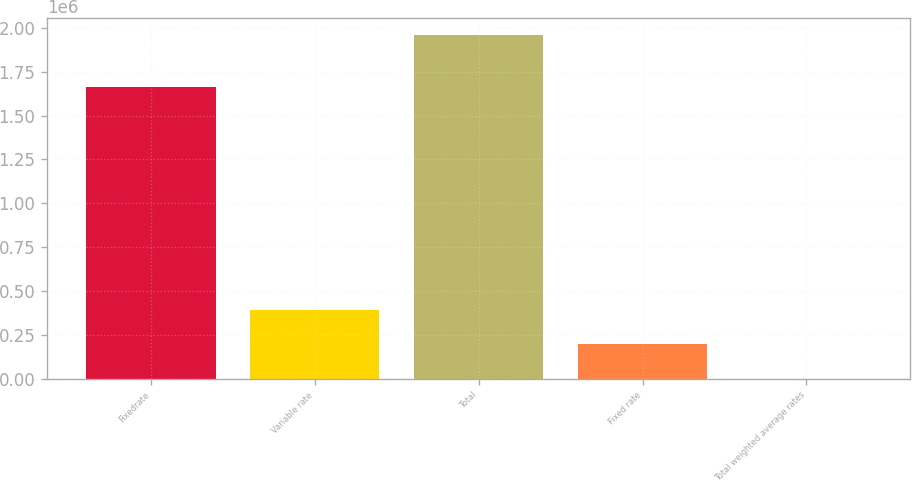<chart> <loc_0><loc_0><loc_500><loc_500><bar_chart><fcel>Fixedrate<fcel>Variable rate<fcel>Total<fcel>Fixed rate<fcel>Total weighted average rates<nl><fcel>1.66317e+06<fcel>391691<fcel>1.95843e+06<fcel>195849<fcel>6.14<nl></chart> 